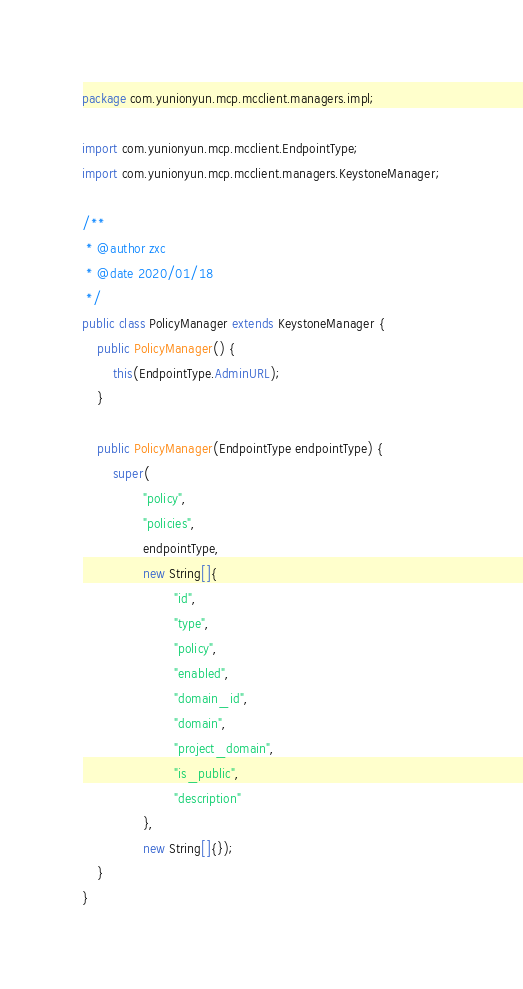Convert code to text. <code><loc_0><loc_0><loc_500><loc_500><_Java_>package com.yunionyun.mcp.mcclient.managers.impl;

import com.yunionyun.mcp.mcclient.EndpointType;
import com.yunionyun.mcp.mcclient.managers.KeystoneManager;

/**
 * @author zxc
 * @date 2020/01/18
 */
public class PolicyManager extends KeystoneManager {
	public PolicyManager() {
		this(EndpointType.AdminURL);
	}

	public PolicyManager(EndpointType endpointType) {
		super(
				"policy",
				"policies",
				endpointType,
				new String[]{
						"id",
						"type",
						"policy",
						"enabled",
						"domain_id",
						"domain",
						"project_domain",
						"is_public",
						"description"
				},
				new String[]{});
	}
}
</code> 